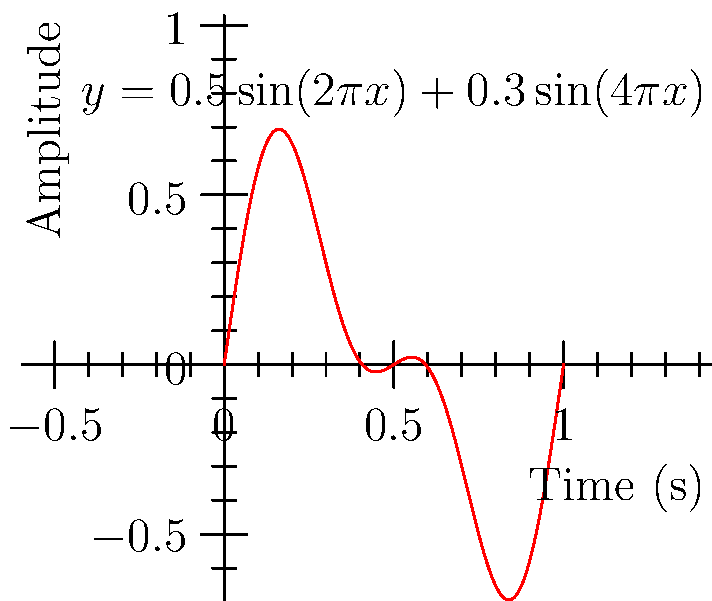A saxophone produces a sound wave represented by the function $y = 0.5\sin(2\pi x) + 0.3\sin(4\pi x)$, where $x$ is time in seconds and $y$ is the amplitude. Calculate the area under this curve from $x=0$ to $x=1$ using a definite integral. To find the area under the curve, we need to integrate the given function from 0 to 1:

1) Set up the definite integral:
   $$\int_0^1 [0.5\sin(2\pi x) + 0.3\sin(4\pi x)] dx$$

2) Integrate each term separately:
   For $0.5\sin(2\pi x)$:
   $$\int 0.5\sin(2\pi x) dx = -\frac{0.5}{2\pi}\cos(2\pi x) + C$$
   
   For $0.3\sin(4\pi x)$:
   $$\int 0.3\sin(4\pi x) dx = -\frac{0.3}{4\pi}\cos(4\pi x) + C$$

3) Apply the fundamental theorem of calculus:
   $$\left[-\frac{0.5}{2\pi}\cos(2\pi x) - \frac{0.3}{4\pi}\cos(4\pi x)\right]_0^1$$

4) Evaluate at the upper and lower bounds:
   $$\left(-\frac{0.5}{2\pi}\cos(2\pi) - \frac{0.3}{4\pi}\cos(4\pi)\right) - \left(-\frac{0.5}{2\pi}\cos(0) - \frac{0.3}{4\pi}\cos(0)\right)$$

5) Simplify:
   $$\left(-\frac{0.5}{2\pi} - \frac{0.3}{4\pi}\right) - \left(-\frac{0.5}{2\pi} - \frac{0.3}{4\pi}\right) = 0$$

The area under the curve from 0 to 1 is zero because the positive and negative areas cancel out over one complete cycle of the wave.
Answer: 0 